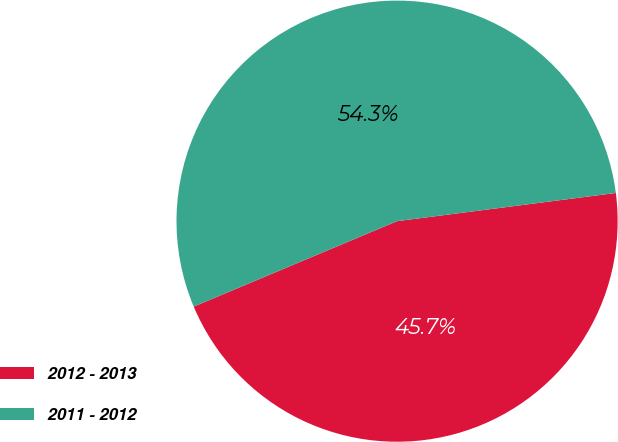<chart> <loc_0><loc_0><loc_500><loc_500><pie_chart><fcel>2012 - 2013<fcel>2011 - 2012<nl><fcel>45.71%<fcel>54.29%<nl></chart> 